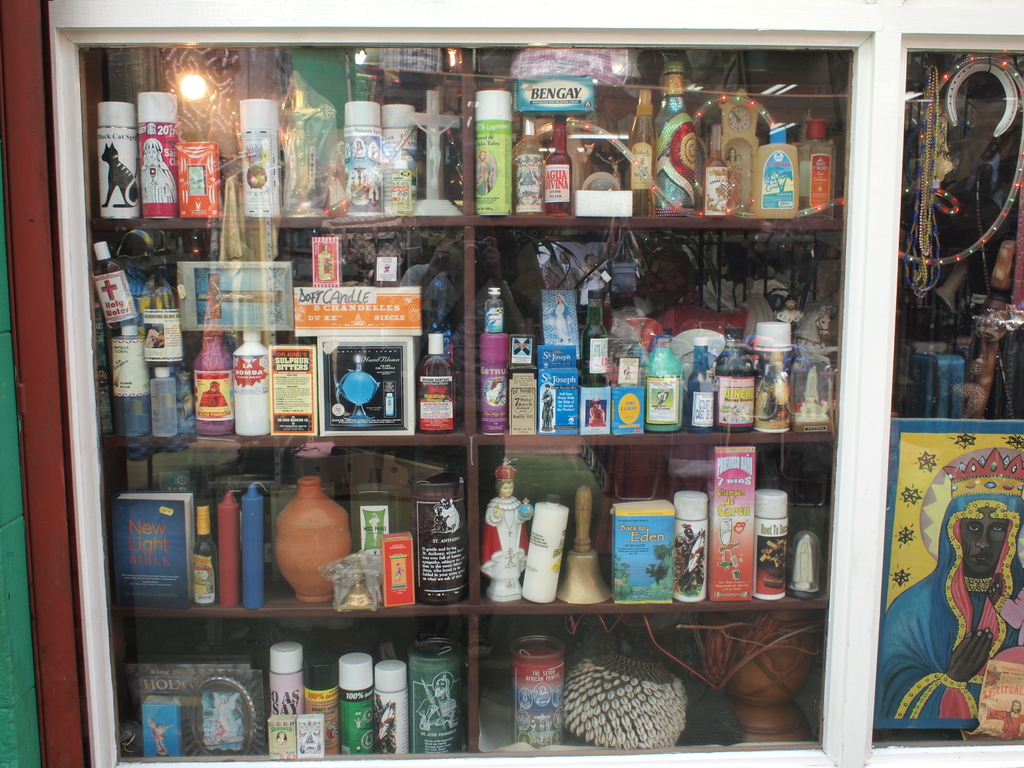Can you explain the significance of the diverse items displayed in this shop window? Certainly! The items in the shop window seem to represent a blend of cultural and religious significance, possibly catering to a varied clientele interested in spirituality, traditional remedies, and cultural artifacts. The collection ranges from religious candles and statues to traditional medicines and books, indicating a thematic focus on both spiritual and physical well-being.  Is there any particular item that stands out due to its unique characteristics or cultural relevance? The 'New Light Bible' and religious candles stand out. These items suggest a focus on spiritual enlightenment and ritual practices. The Bible, often central in many religious practices, paired with candles, often used in prayers and ceremonies, indicates a strong focus on spiritual activities within this community. 